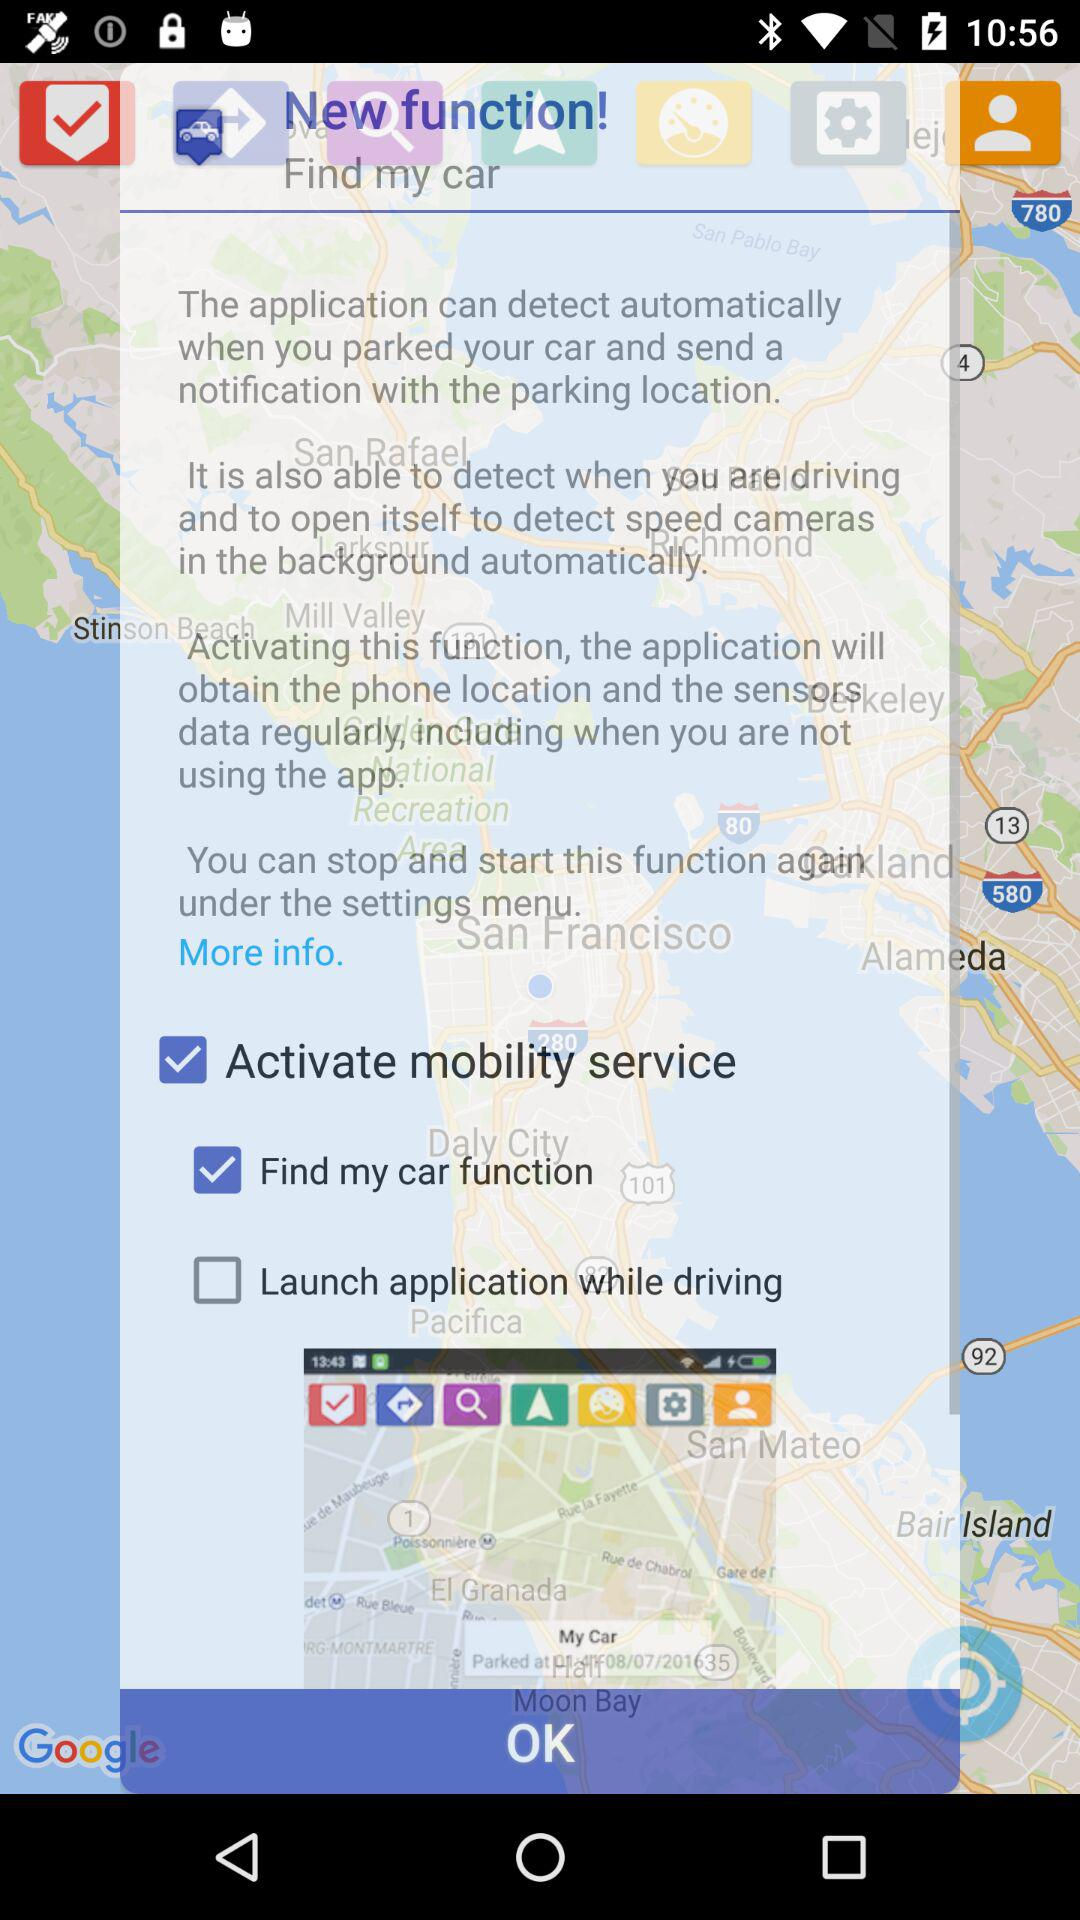What is the current status of the "Activate mobility service"? The current status of the "Activate mobility service" is "on". 